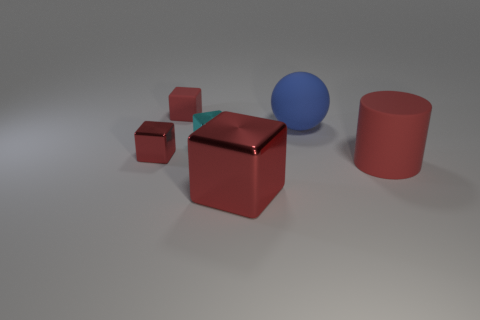Subtract all red cubes. How many were subtracted if there are1red cubes left? 2 Subtract all red cubes. How many cubes are left? 1 Add 2 cylinders. How many objects exist? 8 Subtract all red cylinders. How many red blocks are left? 3 Subtract 1 blocks. How many blocks are left? 3 Subtract all red blocks. How many blocks are left? 1 Subtract all spheres. How many objects are left? 5 Subtract all gray blocks. Subtract all green cylinders. How many blocks are left? 4 Add 3 cylinders. How many cylinders exist? 4 Subtract 0 gray balls. How many objects are left? 6 